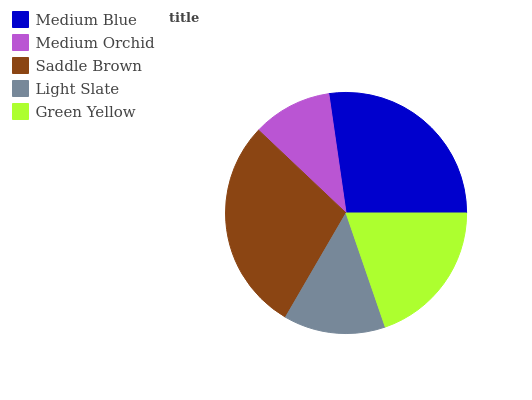Is Medium Orchid the minimum?
Answer yes or no. Yes. Is Saddle Brown the maximum?
Answer yes or no. Yes. Is Saddle Brown the minimum?
Answer yes or no. No. Is Medium Orchid the maximum?
Answer yes or no. No. Is Saddle Brown greater than Medium Orchid?
Answer yes or no. Yes. Is Medium Orchid less than Saddle Brown?
Answer yes or no. Yes. Is Medium Orchid greater than Saddle Brown?
Answer yes or no. No. Is Saddle Brown less than Medium Orchid?
Answer yes or no. No. Is Green Yellow the high median?
Answer yes or no. Yes. Is Green Yellow the low median?
Answer yes or no. Yes. Is Light Slate the high median?
Answer yes or no. No. Is Medium Blue the low median?
Answer yes or no. No. 